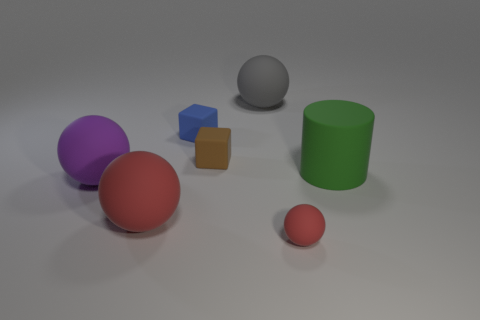Is the size of the green rubber cylinder the same as the red object on the right side of the gray thing?
Offer a terse response. No. There is a big rubber object right of the big ball that is to the right of the small blue rubber thing; what shape is it?
Your response must be concise. Cylinder. Are there fewer large purple matte balls that are behind the small brown object than small purple cylinders?
Provide a succinct answer. No. What is the shape of the rubber object that is the same color as the tiny matte ball?
Give a very brief answer. Sphere. What number of gray balls are the same size as the gray rubber object?
Your response must be concise. 0. What shape is the small rubber object that is in front of the big red rubber ball?
Give a very brief answer. Sphere. Are there fewer blue rubber blocks than brown cylinders?
Make the answer very short. No. Are there any other things that have the same color as the small matte ball?
Your answer should be compact. Yes. There is a block that is in front of the tiny blue cube; how big is it?
Your answer should be very brief. Small. Is the number of large red balls greater than the number of large metallic things?
Your answer should be very brief. Yes. 